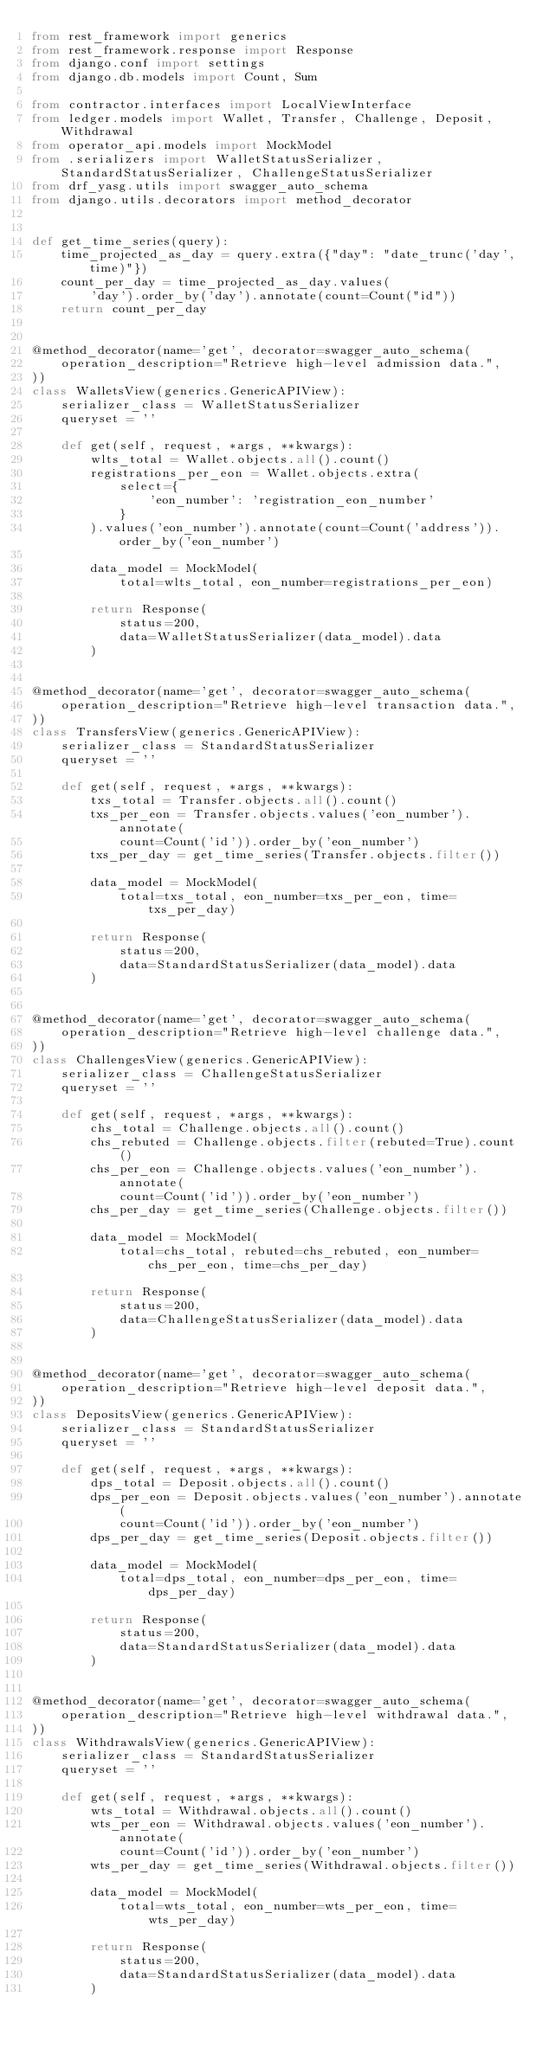Convert code to text. <code><loc_0><loc_0><loc_500><loc_500><_Python_>from rest_framework import generics
from rest_framework.response import Response
from django.conf import settings
from django.db.models import Count, Sum

from contractor.interfaces import LocalViewInterface
from ledger.models import Wallet, Transfer, Challenge, Deposit, Withdrawal
from operator_api.models import MockModel
from .serializers import WalletStatusSerializer, StandardStatusSerializer, ChallengeStatusSerializer
from drf_yasg.utils import swagger_auto_schema
from django.utils.decorators import method_decorator


def get_time_series(query):
    time_projected_as_day = query.extra({"day": "date_trunc('day', time)"})
    count_per_day = time_projected_as_day.values(
        'day').order_by('day').annotate(count=Count("id"))
    return count_per_day


@method_decorator(name='get', decorator=swagger_auto_schema(
    operation_description="Retrieve high-level admission data.",
))
class WalletsView(generics.GenericAPIView):
    serializer_class = WalletStatusSerializer
    queryset = ''

    def get(self, request, *args, **kwargs):
        wlts_total = Wallet.objects.all().count()
        registrations_per_eon = Wallet.objects.extra(
            select={
                'eon_number': 'registration_eon_number'
            }
        ).values('eon_number').annotate(count=Count('address')).order_by('eon_number')

        data_model = MockModel(
            total=wlts_total, eon_number=registrations_per_eon)

        return Response(
            status=200,
            data=WalletStatusSerializer(data_model).data
        )


@method_decorator(name='get', decorator=swagger_auto_schema(
    operation_description="Retrieve high-level transaction data.",
))
class TransfersView(generics.GenericAPIView):
    serializer_class = StandardStatusSerializer
    queryset = ''

    def get(self, request, *args, **kwargs):
        txs_total = Transfer.objects.all().count()
        txs_per_eon = Transfer.objects.values('eon_number').annotate(
            count=Count('id')).order_by('eon_number')
        txs_per_day = get_time_series(Transfer.objects.filter())

        data_model = MockModel(
            total=txs_total, eon_number=txs_per_eon, time=txs_per_day)

        return Response(
            status=200,
            data=StandardStatusSerializer(data_model).data
        )


@method_decorator(name='get', decorator=swagger_auto_schema(
    operation_description="Retrieve high-level challenge data.",
))
class ChallengesView(generics.GenericAPIView):
    serializer_class = ChallengeStatusSerializer
    queryset = ''

    def get(self, request, *args, **kwargs):
        chs_total = Challenge.objects.all().count()
        chs_rebuted = Challenge.objects.filter(rebuted=True).count()
        chs_per_eon = Challenge.objects.values('eon_number').annotate(
            count=Count('id')).order_by('eon_number')
        chs_per_day = get_time_series(Challenge.objects.filter())

        data_model = MockModel(
            total=chs_total, rebuted=chs_rebuted, eon_number=chs_per_eon, time=chs_per_day)

        return Response(
            status=200,
            data=ChallengeStatusSerializer(data_model).data
        )


@method_decorator(name='get', decorator=swagger_auto_schema(
    operation_description="Retrieve high-level deposit data.",
))
class DepositsView(generics.GenericAPIView):
    serializer_class = StandardStatusSerializer
    queryset = ''

    def get(self, request, *args, **kwargs):
        dps_total = Deposit.objects.all().count()
        dps_per_eon = Deposit.objects.values('eon_number').annotate(
            count=Count('id')).order_by('eon_number')
        dps_per_day = get_time_series(Deposit.objects.filter())

        data_model = MockModel(
            total=dps_total, eon_number=dps_per_eon, time=dps_per_day)

        return Response(
            status=200,
            data=StandardStatusSerializer(data_model).data
        )


@method_decorator(name='get', decorator=swagger_auto_schema(
    operation_description="Retrieve high-level withdrawal data.",
))
class WithdrawalsView(generics.GenericAPIView):
    serializer_class = StandardStatusSerializer
    queryset = ''

    def get(self, request, *args, **kwargs):
        wts_total = Withdrawal.objects.all().count()
        wts_per_eon = Withdrawal.objects.values('eon_number').annotate(
            count=Count('id')).order_by('eon_number')
        wts_per_day = get_time_series(Withdrawal.objects.filter())

        data_model = MockModel(
            total=wts_total, eon_number=wts_per_eon, time=wts_per_day)

        return Response(
            status=200,
            data=StandardStatusSerializer(data_model).data
        )
</code> 